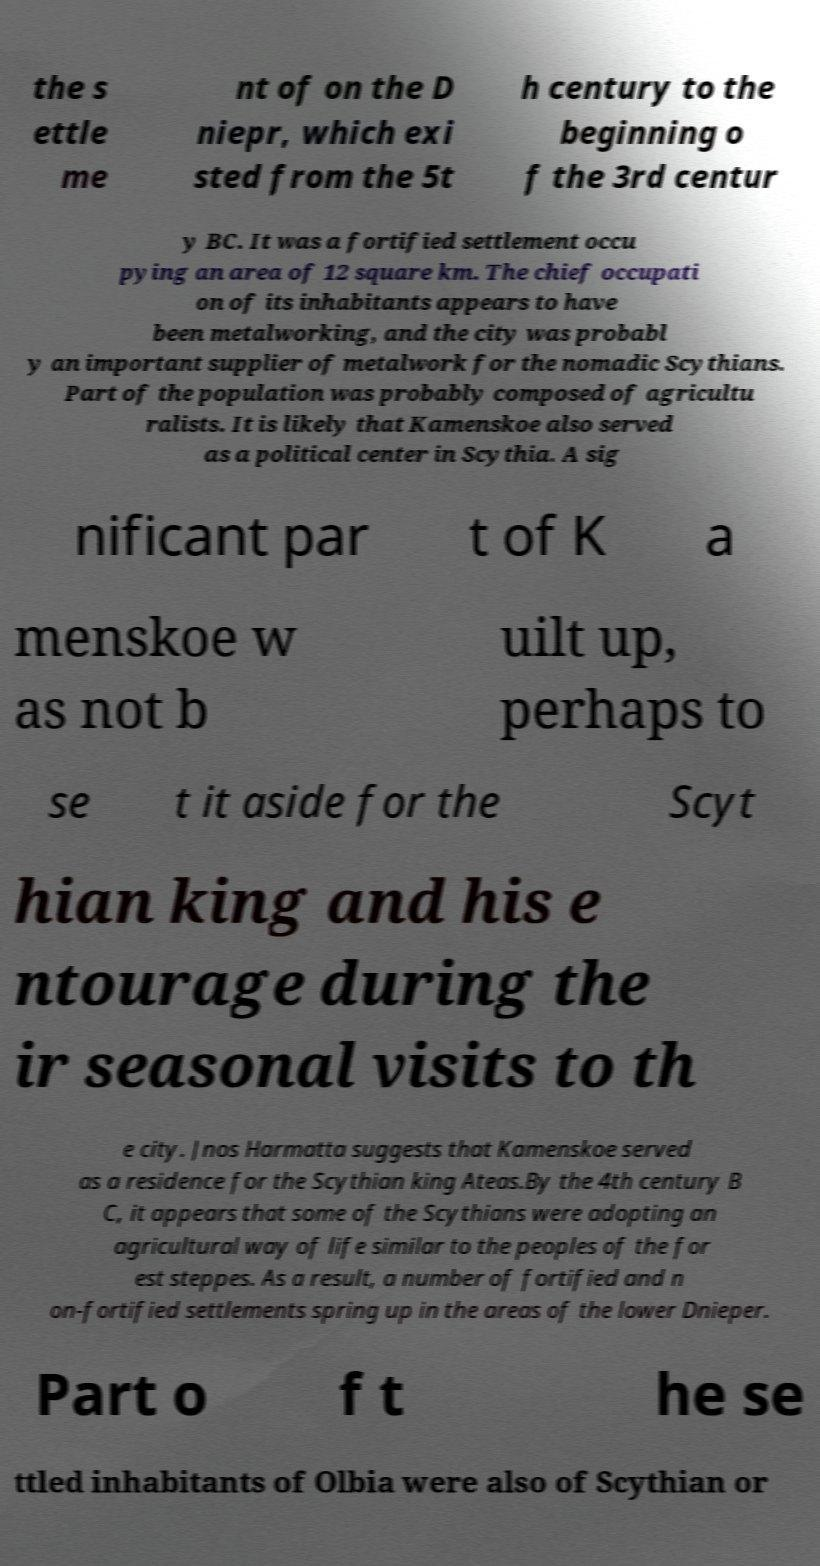What messages or text are displayed in this image? I need them in a readable, typed format. the s ettle me nt of on the D niepr, which exi sted from the 5t h century to the beginning o f the 3rd centur y BC. It was a fortified settlement occu pying an area of 12 square km. The chief occupati on of its inhabitants appears to have been metalworking, and the city was probabl y an important supplier of metalwork for the nomadic Scythians. Part of the population was probably composed of agricultu ralists. It is likely that Kamenskoe also served as a political center in Scythia. A sig nificant par t of K a menskoe w as not b uilt up, perhaps to se t it aside for the Scyt hian king and his e ntourage during the ir seasonal visits to th e city. Jnos Harmatta suggests that Kamenskoe served as a residence for the Scythian king Ateas.By the 4th century B C, it appears that some of the Scythians were adopting an agricultural way of life similar to the peoples of the for est steppes. As a result, a number of fortified and n on-fortified settlements spring up in the areas of the lower Dnieper. Part o f t he se ttled inhabitants of Olbia were also of Scythian or 